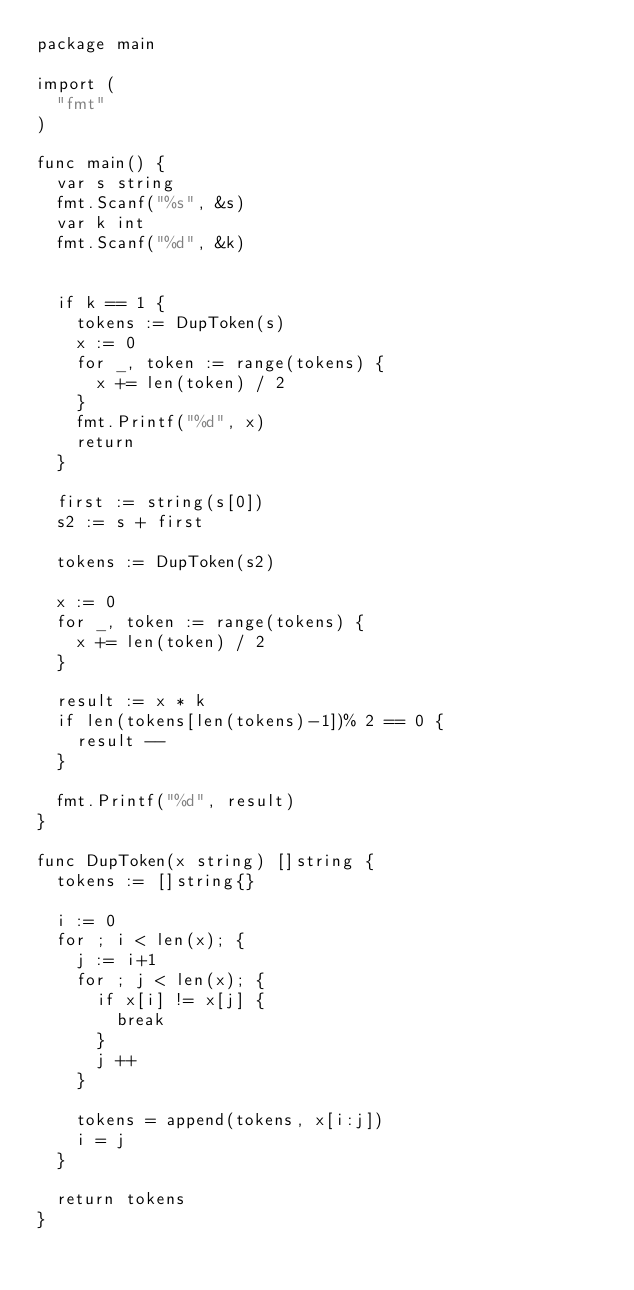Convert code to text. <code><loc_0><loc_0><loc_500><loc_500><_Go_>package main

import (
	"fmt"
)

func main() {
	var s string
	fmt.Scanf("%s", &s)
	var k int
	fmt.Scanf("%d", &k)


	if k == 1 {
		tokens := DupToken(s)
		x := 0
		for _, token := range(tokens) {
			x += len(token) / 2
		}
		fmt.Printf("%d", x)
		return
	}

	first := string(s[0])
	s2 := s + first

	tokens := DupToken(s2)

	x := 0
	for _, token := range(tokens) {
		x += len(token) / 2
	}

	result := x * k
	if len(tokens[len(tokens)-1])% 2 == 0 {
		result --
	}

	fmt.Printf("%d", result)
}

func DupToken(x string) []string {
	tokens := []string{}

	i := 0
	for ; i < len(x); {
		j := i+1
		for ; j < len(x); {
			if x[i] != x[j] {
				break
			}
			j ++
		}

		tokens = append(tokens, x[i:j])
		i = j
	}

	return tokens
}

</code> 